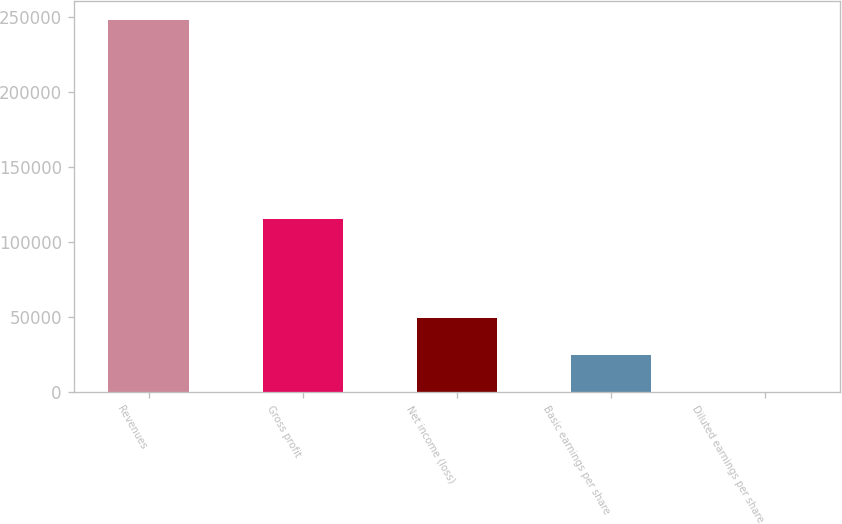<chart> <loc_0><loc_0><loc_500><loc_500><bar_chart><fcel>Revenues<fcel>Gross profit<fcel>Net income (loss)<fcel>Basic earnings per share<fcel>Diluted earnings per share<nl><fcel>248649<fcel>115599<fcel>49730.1<fcel>24865.2<fcel>0.35<nl></chart> 